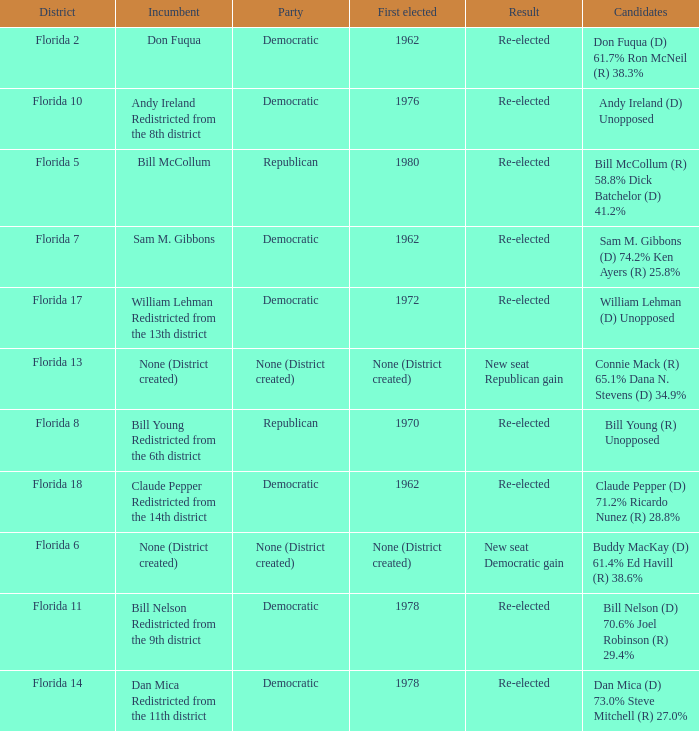What's the district with result being new seat democratic gain Florida 6. 